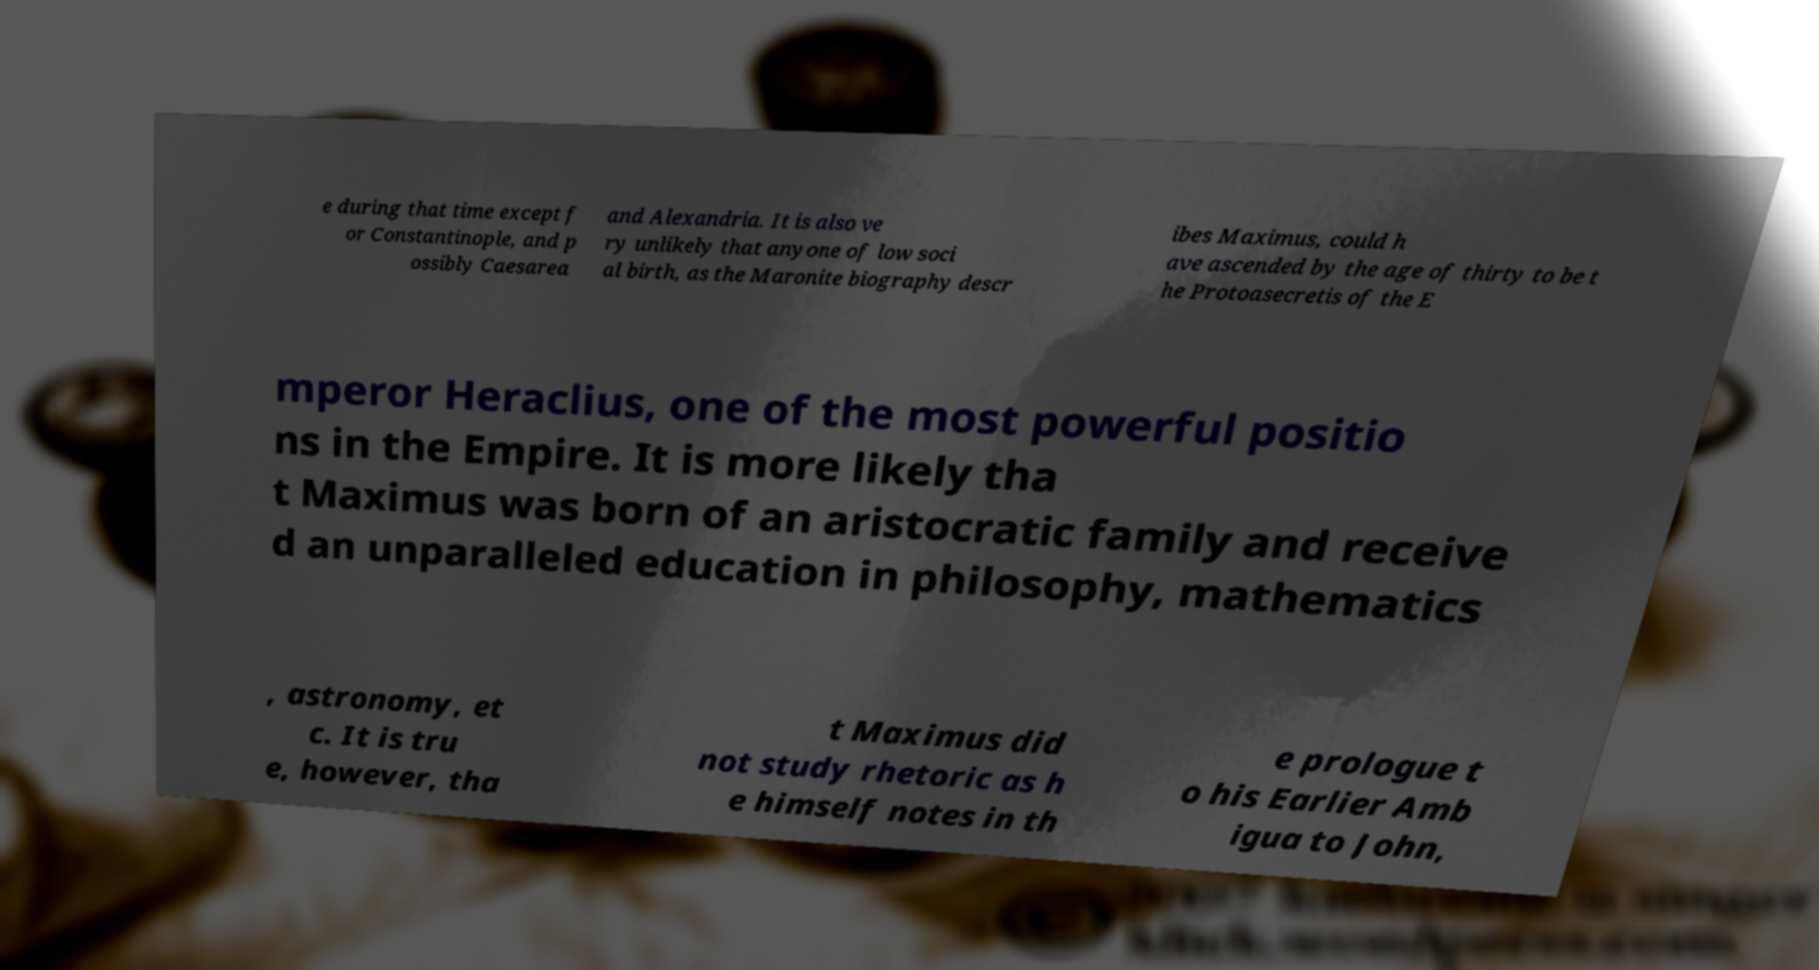What messages or text are displayed in this image? I need them in a readable, typed format. e during that time except f or Constantinople, and p ossibly Caesarea and Alexandria. It is also ve ry unlikely that anyone of low soci al birth, as the Maronite biography descr ibes Maximus, could h ave ascended by the age of thirty to be t he Protoasecretis of the E mperor Heraclius, one of the most powerful positio ns in the Empire. It is more likely tha t Maximus was born of an aristocratic family and receive d an unparalleled education in philosophy, mathematics , astronomy, et c. It is tru e, however, tha t Maximus did not study rhetoric as h e himself notes in th e prologue t o his Earlier Amb igua to John, 